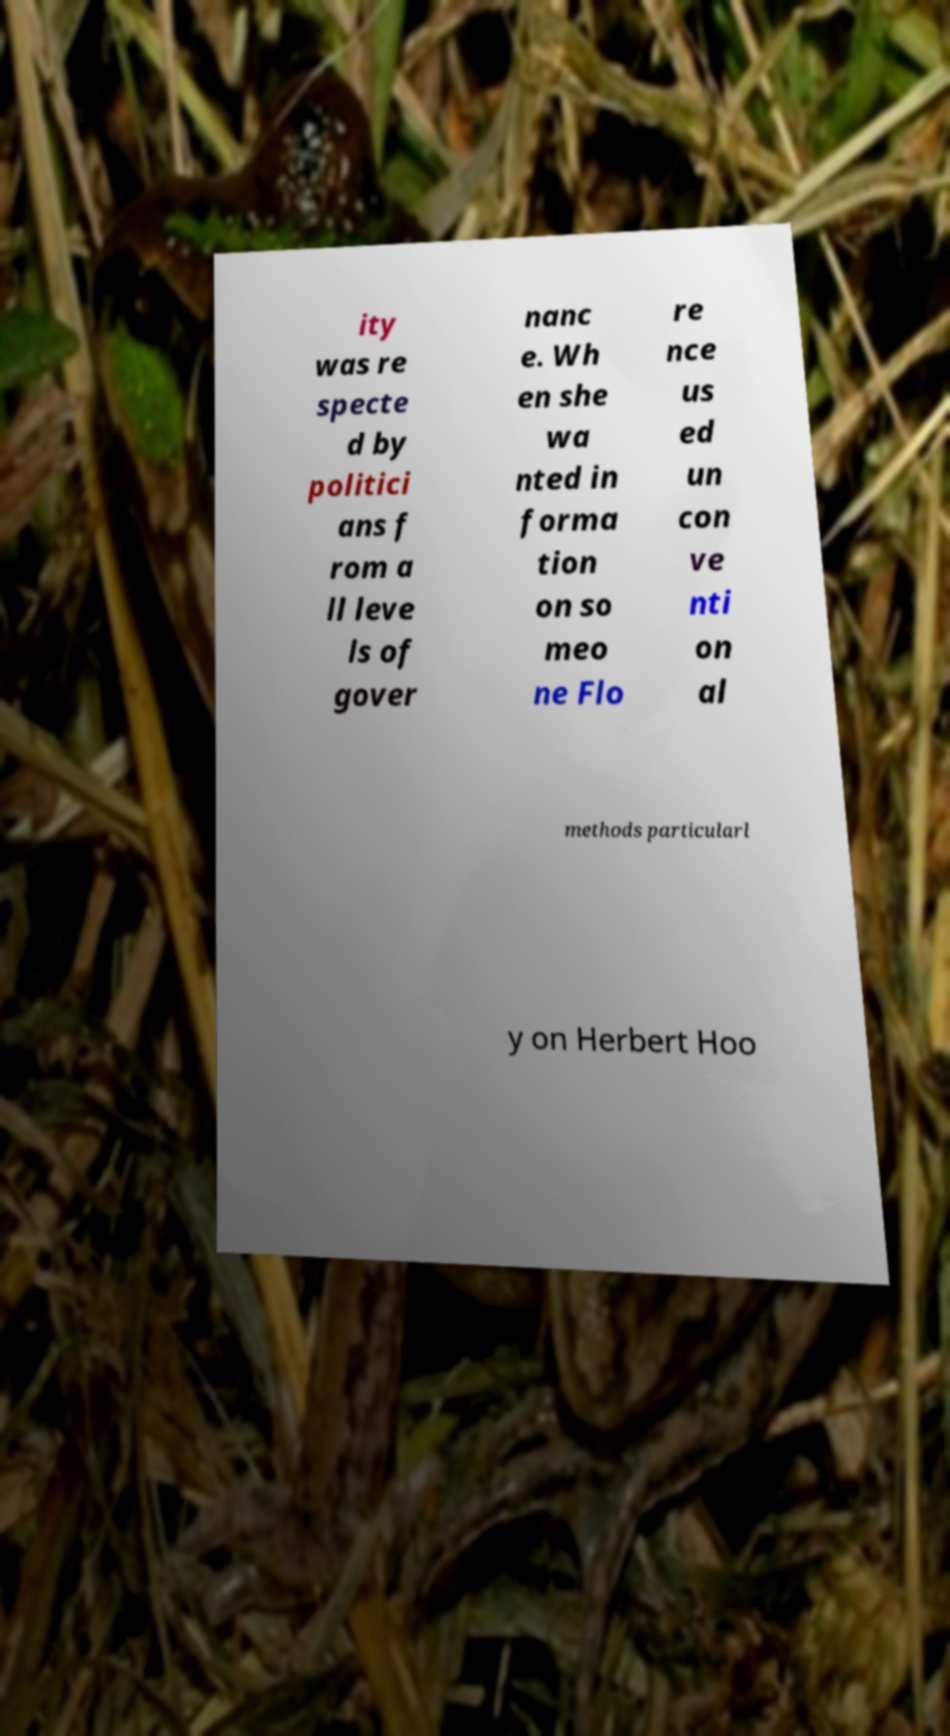Can you read and provide the text displayed in the image?This photo seems to have some interesting text. Can you extract and type it out for me? ity was re specte d by politici ans f rom a ll leve ls of gover nanc e. Wh en she wa nted in forma tion on so meo ne Flo re nce us ed un con ve nti on al methods particularl y on Herbert Hoo 